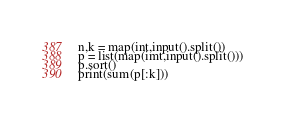<code> <loc_0><loc_0><loc_500><loc_500><_Python_>n,k = map(int,input().split())
p = list(map(imt,input().split()))
p.sort()
print(sum(p[:k]))</code> 